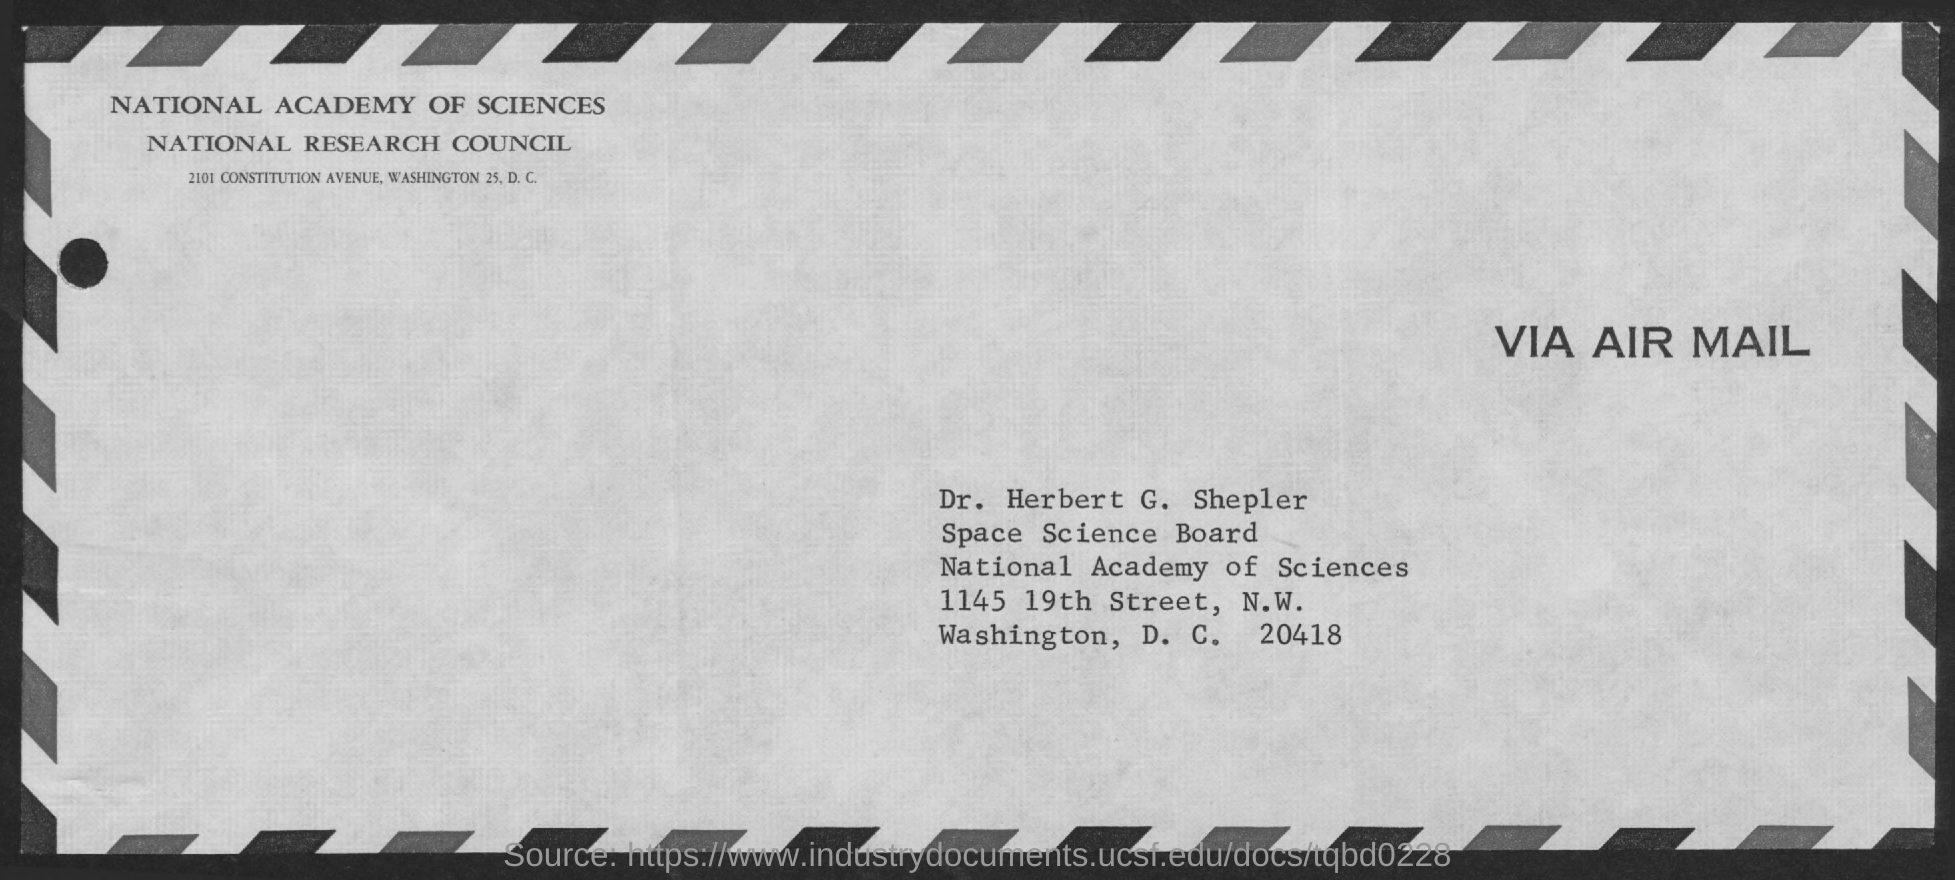Identify some key points in this picture. The recipient of the air mail is Dr. Herbert G. Shepler. 